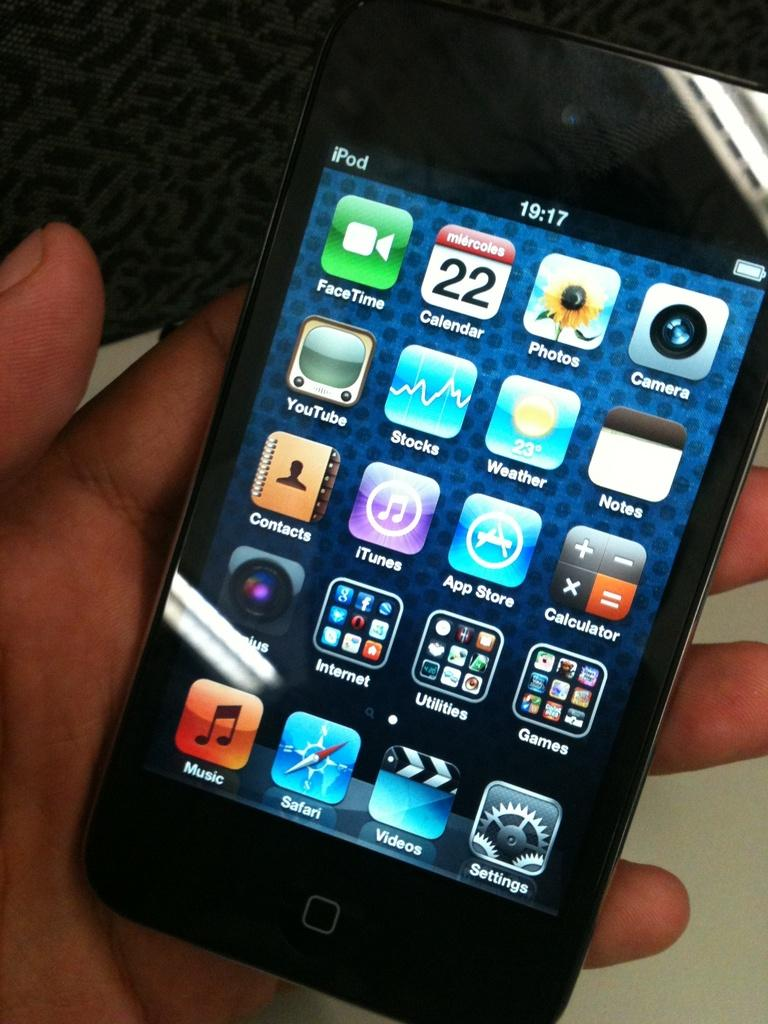<image>
Present a compact description of the photo's key features. An Iphone display shows the Calendar and Photo apps next to each other 